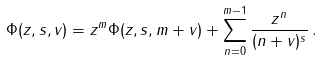Convert formula to latex. <formula><loc_0><loc_0><loc_500><loc_500>\Phi ( z , s , v ) = z ^ { m } \Phi ( z , s , m + v ) + \sum _ { n = 0 } ^ { m - 1 } \frac { z ^ { n } } { ( n + v ) ^ { s } } \, .</formula> 